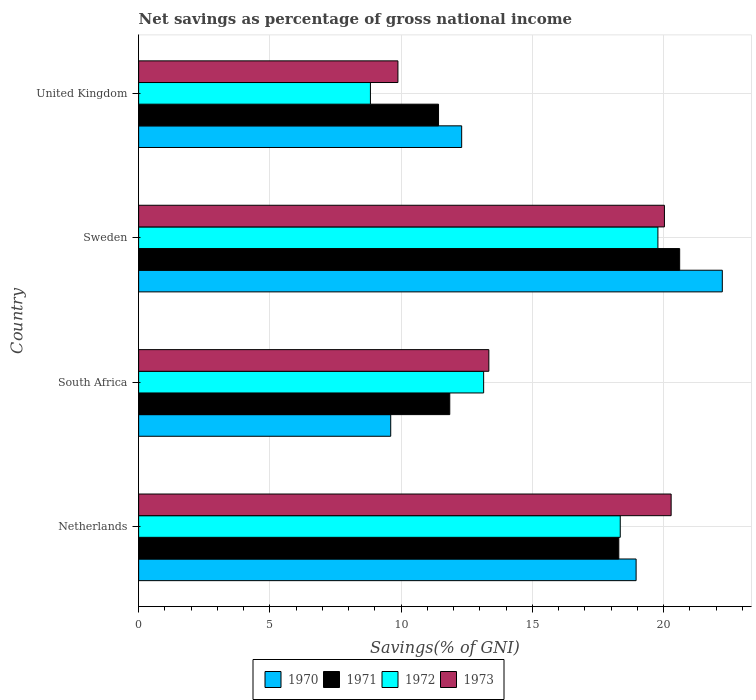How many groups of bars are there?
Ensure brevity in your answer.  4. Are the number of bars on each tick of the Y-axis equal?
Offer a very short reply. Yes. How many bars are there on the 3rd tick from the bottom?
Your response must be concise. 4. What is the total savings in 1970 in South Africa?
Your answer should be compact. 9.6. Across all countries, what is the maximum total savings in 1972?
Offer a terse response. 19.78. Across all countries, what is the minimum total savings in 1972?
Give a very brief answer. 8.83. In which country was the total savings in 1970 maximum?
Your answer should be compact. Sweden. In which country was the total savings in 1971 minimum?
Keep it short and to the point. United Kingdom. What is the total total savings in 1973 in the graph?
Offer a very short reply. 63.54. What is the difference between the total savings in 1971 in Netherlands and that in United Kingdom?
Provide a short and direct response. 6.87. What is the difference between the total savings in 1971 in Sweden and the total savings in 1970 in South Africa?
Give a very brief answer. 11.01. What is the average total savings in 1972 per country?
Your answer should be very brief. 15.03. What is the difference between the total savings in 1970 and total savings in 1973 in Netherlands?
Give a very brief answer. -1.33. In how many countries, is the total savings in 1971 greater than 11 %?
Offer a terse response. 4. What is the ratio of the total savings in 1970 in South Africa to that in United Kingdom?
Ensure brevity in your answer.  0.78. Is the total savings in 1973 in South Africa less than that in Sweden?
Offer a very short reply. Yes. What is the difference between the highest and the second highest total savings in 1973?
Your answer should be compact. 0.26. What is the difference between the highest and the lowest total savings in 1971?
Your answer should be very brief. 9.19. What does the 4th bar from the bottom in South Africa represents?
Offer a terse response. 1973. How many countries are there in the graph?
Make the answer very short. 4. What is the difference between two consecutive major ticks on the X-axis?
Make the answer very short. 5. Does the graph contain any zero values?
Ensure brevity in your answer.  No. Where does the legend appear in the graph?
Ensure brevity in your answer.  Bottom center. How many legend labels are there?
Provide a short and direct response. 4. What is the title of the graph?
Provide a short and direct response. Net savings as percentage of gross national income. What is the label or title of the X-axis?
Offer a very short reply. Savings(% of GNI). What is the Savings(% of GNI) in 1970 in Netherlands?
Make the answer very short. 18.95. What is the Savings(% of GNI) in 1971 in Netherlands?
Provide a short and direct response. 18.29. What is the Savings(% of GNI) in 1972 in Netherlands?
Provide a succinct answer. 18.35. What is the Savings(% of GNI) in 1973 in Netherlands?
Provide a short and direct response. 20.29. What is the Savings(% of GNI) in 1970 in South Africa?
Provide a succinct answer. 9.6. What is the Savings(% of GNI) of 1971 in South Africa?
Your answer should be compact. 11.85. What is the Savings(% of GNI) in 1972 in South Africa?
Provide a succinct answer. 13.14. What is the Savings(% of GNI) of 1973 in South Africa?
Your answer should be very brief. 13.34. What is the Savings(% of GNI) of 1970 in Sweden?
Ensure brevity in your answer.  22.24. What is the Savings(% of GNI) of 1971 in Sweden?
Offer a very short reply. 20.61. What is the Savings(% of GNI) in 1972 in Sweden?
Give a very brief answer. 19.78. What is the Savings(% of GNI) in 1973 in Sweden?
Your response must be concise. 20.03. What is the Savings(% of GNI) of 1970 in United Kingdom?
Offer a very short reply. 12.31. What is the Savings(% of GNI) of 1971 in United Kingdom?
Ensure brevity in your answer.  11.43. What is the Savings(% of GNI) in 1972 in United Kingdom?
Keep it short and to the point. 8.83. What is the Savings(% of GNI) in 1973 in United Kingdom?
Provide a short and direct response. 9.88. Across all countries, what is the maximum Savings(% of GNI) of 1970?
Offer a very short reply. 22.24. Across all countries, what is the maximum Savings(% of GNI) in 1971?
Offer a terse response. 20.61. Across all countries, what is the maximum Savings(% of GNI) in 1972?
Make the answer very short. 19.78. Across all countries, what is the maximum Savings(% of GNI) in 1973?
Provide a succinct answer. 20.29. Across all countries, what is the minimum Savings(% of GNI) in 1970?
Ensure brevity in your answer.  9.6. Across all countries, what is the minimum Savings(% of GNI) in 1971?
Make the answer very short. 11.43. Across all countries, what is the minimum Savings(% of GNI) in 1972?
Offer a terse response. 8.83. Across all countries, what is the minimum Savings(% of GNI) of 1973?
Make the answer very short. 9.88. What is the total Savings(% of GNI) of 1970 in the graph?
Offer a very short reply. 63.1. What is the total Savings(% of GNI) in 1971 in the graph?
Your answer should be very brief. 62.19. What is the total Savings(% of GNI) of 1972 in the graph?
Make the answer very short. 60.11. What is the total Savings(% of GNI) in 1973 in the graph?
Your answer should be compact. 63.54. What is the difference between the Savings(% of GNI) of 1970 in Netherlands and that in South Africa?
Offer a terse response. 9.35. What is the difference between the Savings(% of GNI) of 1971 in Netherlands and that in South Africa?
Your response must be concise. 6.44. What is the difference between the Savings(% of GNI) of 1972 in Netherlands and that in South Africa?
Keep it short and to the point. 5.21. What is the difference between the Savings(% of GNI) in 1973 in Netherlands and that in South Africa?
Make the answer very short. 6.95. What is the difference between the Savings(% of GNI) in 1970 in Netherlands and that in Sweden?
Your answer should be compact. -3.28. What is the difference between the Savings(% of GNI) in 1971 in Netherlands and that in Sweden?
Your answer should be very brief. -2.32. What is the difference between the Savings(% of GNI) of 1972 in Netherlands and that in Sweden?
Provide a succinct answer. -1.43. What is the difference between the Savings(% of GNI) of 1973 in Netherlands and that in Sweden?
Give a very brief answer. 0.26. What is the difference between the Savings(% of GNI) of 1970 in Netherlands and that in United Kingdom?
Keep it short and to the point. 6.65. What is the difference between the Savings(% of GNI) of 1971 in Netherlands and that in United Kingdom?
Your answer should be very brief. 6.87. What is the difference between the Savings(% of GNI) of 1972 in Netherlands and that in United Kingdom?
Keep it short and to the point. 9.52. What is the difference between the Savings(% of GNI) in 1973 in Netherlands and that in United Kingdom?
Your answer should be very brief. 10.41. What is the difference between the Savings(% of GNI) of 1970 in South Africa and that in Sweden?
Ensure brevity in your answer.  -12.63. What is the difference between the Savings(% of GNI) of 1971 in South Africa and that in Sweden?
Ensure brevity in your answer.  -8.76. What is the difference between the Savings(% of GNI) of 1972 in South Africa and that in Sweden?
Provide a short and direct response. -6.64. What is the difference between the Savings(% of GNI) of 1973 in South Africa and that in Sweden?
Your response must be concise. -6.69. What is the difference between the Savings(% of GNI) in 1970 in South Africa and that in United Kingdom?
Provide a succinct answer. -2.7. What is the difference between the Savings(% of GNI) of 1971 in South Africa and that in United Kingdom?
Give a very brief answer. 0.43. What is the difference between the Savings(% of GNI) of 1972 in South Africa and that in United Kingdom?
Make the answer very short. 4.31. What is the difference between the Savings(% of GNI) of 1973 in South Africa and that in United Kingdom?
Offer a very short reply. 3.46. What is the difference between the Savings(% of GNI) in 1970 in Sweden and that in United Kingdom?
Provide a short and direct response. 9.93. What is the difference between the Savings(% of GNI) of 1971 in Sweden and that in United Kingdom?
Your response must be concise. 9.19. What is the difference between the Savings(% of GNI) of 1972 in Sweden and that in United Kingdom?
Give a very brief answer. 10.95. What is the difference between the Savings(% of GNI) in 1973 in Sweden and that in United Kingdom?
Give a very brief answer. 10.15. What is the difference between the Savings(% of GNI) in 1970 in Netherlands and the Savings(% of GNI) in 1971 in South Africa?
Give a very brief answer. 7.1. What is the difference between the Savings(% of GNI) in 1970 in Netherlands and the Savings(% of GNI) in 1972 in South Africa?
Ensure brevity in your answer.  5.81. What is the difference between the Savings(% of GNI) in 1970 in Netherlands and the Savings(% of GNI) in 1973 in South Africa?
Your answer should be compact. 5.61. What is the difference between the Savings(% of GNI) of 1971 in Netherlands and the Savings(% of GNI) of 1972 in South Africa?
Give a very brief answer. 5.15. What is the difference between the Savings(% of GNI) in 1971 in Netherlands and the Savings(% of GNI) in 1973 in South Africa?
Your answer should be compact. 4.95. What is the difference between the Savings(% of GNI) in 1972 in Netherlands and the Savings(% of GNI) in 1973 in South Africa?
Make the answer very short. 5.01. What is the difference between the Savings(% of GNI) of 1970 in Netherlands and the Savings(% of GNI) of 1971 in Sweden?
Your response must be concise. -1.66. What is the difference between the Savings(% of GNI) of 1970 in Netherlands and the Savings(% of GNI) of 1972 in Sweden?
Provide a succinct answer. -0.83. What is the difference between the Savings(% of GNI) in 1970 in Netherlands and the Savings(% of GNI) in 1973 in Sweden?
Offer a very short reply. -1.08. What is the difference between the Savings(% of GNI) of 1971 in Netherlands and the Savings(% of GNI) of 1972 in Sweden?
Keep it short and to the point. -1.49. What is the difference between the Savings(% of GNI) in 1971 in Netherlands and the Savings(% of GNI) in 1973 in Sweden?
Ensure brevity in your answer.  -1.74. What is the difference between the Savings(% of GNI) in 1972 in Netherlands and the Savings(% of GNI) in 1973 in Sweden?
Your response must be concise. -1.68. What is the difference between the Savings(% of GNI) of 1970 in Netherlands and the Savings(% of GNI) of 1971 in United Kingdom?
Keep it short and to the point. 7.53. What is the difference between the Savings(% of GNI) in 1970 in Netherlands and the Savings(% of GNI) in 1972 in United Kingdom?
Your response must be concise. 10.12. What is the difference between the Savings(% of GNI) in 1970 in Netherlands and the Savings(% of GNI) in 1973 in United Kingdom?
Your answer should be very brief. 9.07. What is the difference between the Savings(% of GNI) in 1971 in Netherlands and the Savings(% of GNI) in 1972 in United Kingdom?
Your answer should be compact. 9.46. What is the difference between the Savings(% of GNI) of 1971 in Netherlands and the Savings(% of GNI) of 1973 in United Kingdom?
Keep it short and to the point. 8.42. What is the difference between the Savings(% of GNI) in 1972 in Netherlands and the Savings(% of GNI) in 1973 in United Kingdom?
Make the answer very short. 8.47. What is the difference between the Savings(% of GNI) of 1970 in South Africa and the Savings(% of GNI) of 1971 in Sweden?
Provide a succinct answer. -11.01. What is the difference between the Savings(% of GNI) of 1970 in South Africa and the Savings(% of GNI) of 1972 in Sweden?
Make the answer very short. -10.18. What is the difference between the Savings(% of GNI) in 1970 in South Africa and the Savings(% of GNI) in 1973 in Sweden?
Your response must be concise. -10.43. What is the difference between the Savings(% of GNI) of 1971 in South Africa and the Savings(% of GNI) of 1972 in Sweden?
Provide a short and direct response. -7.93. What is the difference between the Savings(% of GNI) of 1971 in South Africa and the Savings(% of GNI) of 1973 in Sweden?
Your response must be concise. -8.18. What is the difference between the Savings(% of GNI) in 1972 in South Africa and the Savings(% of GNI) in 1973 in Sweden?
Your answer should be very brief. -6.89. What is the difference between the Savings(% of GNI) of 1970 in South Africa and the Savings(% of GNI) of 1971 in United Kingdom?
Ensure brevity in your answer.  -1.82. What is the difference between the Savings(% of GNI) in 1970 in South Africa and the Savings(% of GNI) in 1972 in United Kingdom?
Provide a succinct answer. 0.77. What is the difference between the Savings(% of GNI) of 1970 in South Africa and the Savings(% of GNI) of 1973 in United Kingdom?
Give a very brief answer. -0.27. What is the difference between the Savings(% of GNI) in 1971 in South Africa and the Savings(% of GNI) in 1972 in United Kingdom?
Your response must be concise. 3.02. What is the difference between the Savings(% of GNI) in 1971 in South Africa and the Savings(% of GNI) in 1973 in United Kingdom?
Offer a terse response. 1.98. What is the difference between the Savings(% of GNI) of 1972 in South Africa and the Savings(% of GNI) of 1973 in United Kingdom?
Offer a very short reply. 3.27. What is the difference between the Savings(% of GNI) of 1970 in Sweden and the Savings(% of GNI) of 1971 in United Kingdom?
Offer a terse response. 10.81. What is the difference between the Savings(% of GNI) of 1970 in Sweden and the Savings(% of GNI) of 1972 in United Kingdom?
Your answer should be compact. 13.41. What is the difference between the Savings(% of GNI) in 1970 in Sweden and the Savings(% of GNI) in 1973 in United Kingdom?
Your answer should be compact. 12.36. What is the difference between the Savings(% of GNI) in 1971 in Sweden and the Savings(% of GNI) in 1972 in United Kingdom?
Give a very brief answer. 11.78. What is the difference between the Savings(% of GNI) of 1971 in Sweden and the Savings(% of GNI) of 1973 in United Kingdom?
Provide a succinct answer. 10.73. What is the difference between the Savings(% of GNI) of 1972 in Sweden and the Savings(% of GNI) of 1973 in United Kingdom?
Make the answer very short. 9.91. What is the average Savings(% of GNI) of 1970 per country?
Give a very brief answer. 15.78. What is the average Savings(% of GNI) of 1971 per country?
Provide a short and direct response. 15.55. What is the average Savings(% of GNI) in 1972 per country?
Provide a succinct answer. 15.03. What is the average Savings(% of GNI) of 1973 per country?
Your response must be concise. 15.88. What is the difference between the Savings(% of GNI) in 1970 and Savings(% of GNI) in 1971 in Netherlands?
Ensure brevity in your answer.  0.66. What is the difference between the Savings(% of GNI) of 1970 and Savings(% of GNI) of 1972 in Netherlands?
Provide a succinct answer. 0.6. What is the difference between the Savings(% of GNI) in 1970 and Savings(% of GNI) in 1973 in Netherlands?
Offer a terse response. -1.33. What is the difference between the Savings(% of GNI) in 1971 and Savings(% of GNI) in 1972 in Netherlands?
Ensure brevity in your answer.  -0.06. What is the difference between the Savings(% of GNI) of 1971 and Savings(% of GNI) of 1973 in Netherlands?
Provide a short and direct response. -1.99. What is the difference between the Savings(% of GNI) in 1972 and Savings(% of GNI) in 1973 in Netherlands?
Provide a succinct answer. -1.94. What is the difference between the Savings(% of GNI) of 1970 and Savings(% of GNI) of 1971 in South Africa?
Keep it short and to the point. -2.25. What is the difference between the Savings(% of GNI) of 1970 and Savings(% of GNI) of 1972 in South Africa?
Ensure brevity in your answer.  -3.54. What is the difference between the Savings(% of GNI) of 1970 and Savings(% of GNI) of 1973 in South Africa?
Offer a very short reply. -3.74. What is the difference between the Savings(% of GNI) in 1971 and Savings(% of GNI) in 1972 in South Africa?
Provide a short and direct response. -1.29. What is the difference between the Savings(% of GNI) in 1971 and Savings(% of GNI) in 1973 in South Africa?
Your answer should be very brief. -1.49. What is the difference between the Savings(% of GNI) in 1972 and Savings(% of GNI) in 1973 in South Africa?
Give a very brief answer. -0.2. What is the difference between the Savings(% of GNI) in 1970 and Savings(% of GNI) in 1971 in Sweden?
Make the answer very short. 1.62. What is the difference between the Savings(% of GNI) in 1970 and Savings(% of GNI) in 1972 in Sweden?
Ensure brevity in your answer.  2.45. What is the difference between the Savings(% of GNI) of 1970 and Savings(% of GNI) of 1973 in Sweden?
Your response must be concise. 2.21. What is the difference between the Savings(% of GNI) of 1971 and Savings(% of GNI) of 1972 in Sweden?
Provide a short and direct response. 0.83. What is the difference between the Savings(% of GNI) in 1971 and Savings(% of GNI) in 1973 in Sweden?
Make the answer very short. 0.58. What is the difference between the Savings(% of GNI) in 1972 and Savings(% of GNI) in 1973 in Sweden?
Offer a terse response. -0.25. What is the difference between the Savings(% of GNI) of 1970 and Savings(% of GNI) of 1971 in United Kingdom?
Provide a short and direct response. 0.88. What is the difference between the Savings(% of GNI) of 1970 and Savings(% of GNI) of 1972 in United Kingdom?
Offer a very short reply. 3.48. What is the difference between the Savings(% of GNI) of 1970 and Savings(% of GNI) of 1973 in United Kingdom?
Your answer should be very brief. 2.43. What is the difference between the Savings(% of GNI) of 1971 and Savings(% of GNI) of 1972 in United Kingdom?
Keep it short and to the point. 2.59. What is the difference between the Savings(% of GNI) in 1971 and Savings(% of GNI) in 1973 in United Kingdom?
Offer a terse response. 1.55. What is the difference between the Savings(% of GNI) in 1972 and Savings(% of GNI) in 1973 in United Kingdom?
Your answer should be compact. -1.05. What is the ratio of the Savings(% of GNI) in 1970 in Netherlands to that in South Africa?
Your answer should be very brief. 1.97. What is the ratio of the Savings(% of GNI) of 1971 in Netherlands to that in South Africa?
Your response must be concise. 1.54. What is the ratio of the Savings(% of GNI) in 1972 in Netherlands to that in South Africa?
Provide a succinct answer. 1.4. What is the ratio of the Savings(% of GNI) in 1973 in Netherlands to that in South Africa?
Provide a short and direct response. 1.52. What is the ratio of the Savings(% of GNI) of 1970 in Netherlands to that in Sweden?
Keep it short and to the point. 0.85. What is the ratio of the Savings(% of GNI) in 1971 in Netherlands to that in Sweden?
Provide a short and direct response. 0.89. What is the ratio of the Savings(% of GNI) of 1972 in Netherlands to that in Sweden?
Provide a succinct answer. 0.93. What is the ratio of the Savings(% of GNI) of 1973 in Netherlands to that in Sweden?
Keep it short and to the point. 1.01. What is the ratio of the Savings(% of GNI) in 1970 in Netherlands to that in United Kingdom?
Your answer should be compact. 1.54. What is the ratio of the Savings(% of GNI) in 1971 in Netherlands to that in United Kingdom?
Keep it short and to the point. 1.6. What is the ratio of the Savings(% of GNI) in 1972 in Netherlands to that in United Kingdom?
Your response must be concise. 2.08. What is the ratio of the Savings(% of GNI) in 1973 in Netherlands to that in United Kingdom?
Provide a short and direct response. 2.05. What is the ratio of the Savings(% of GNI) in 1970 in South Africa to that in Sweden?
Ensure brevity in your answer.  0.43. What is the ratio of the Savings(% of GNI) of 1971 in South Africa to that in Sweden?
Your response must be concise. 0.58. What is the ratio of the Savings(% of GNI) of 1972 in South Africa to that in Sweden?
Give a very brief answer. 0.66. What is the ratio of the Savings(% of GNI) of 1973 in South Africa to that in Sweden?
Keep it short and to the point. 0.67. What is the ratio of the Savings(% of GNI) of 1970 in South Africa to that in United Kingdom?
Give a very brief answer. 0.78. What is the ratio of the Savings(% of GNI) in 1971 in South Africa to that in United Kingdom?
Give a very brief answer. 1.04. What is the ratio of the Savings(% of GNI) of 1972 in South Africa to that in United Kingdom?
Give a very brief answer. 1.49. What is the ratio of the Savings(% of GNI) of 1973 in South Africa to that in United Kingdom?
Offer a very short reply. 1.35. What is the ratio of the Savings(% of GNI) in 1970 in Sweden to that in United Kingdom?
Keep it short and to the point. 1.81. What is the ratio of the Savings(% of GNI) of 1971 in Sweden to that in United Kingdom?
Keep it short and to the point. 1.8. What is the ratio of the Savings(% of GNI) of 1972 in Sweden to that in United Kingdom?
Your answer should be compact. 2.24. What is the ratio of the Savings(% of GNI) in 1973 in Sweden to that in United Kingdom?
Make the answer very short. 2.03. What is the difference between the highest and the second highest Savings(% of GNI) in 1970?
Your answer should be very brief. 3.28. What is the difference between the highest and the second highest Savings(% of GNI) in 1971?
Provide a short and direct response. 2.32. What is the difference between the highest and the second highest Savings(% of GNI) of 1972?
Offer a terse response. 1.43. What is the difference between the highest and the second highest Savings(% of GNI) of 1973?
Ensure brevity in your answer.  0.26. What is the difference between the highest and the lowest Savings(% of GNI) of 1970?
Make the answer very short. 12.63. What is the difference between the highest and the lowest Savings(% of GNI) of 1971?
Make the answer very short. 9.19. What is the difference between the highest and the lowest Savings(% of GNI) of 1972?
Your answer should be very brief. 10.95. What is the difference between the highest and the lowest Savings(% of GNI) of 1973?
Keep it short and to the point. 10.41. 